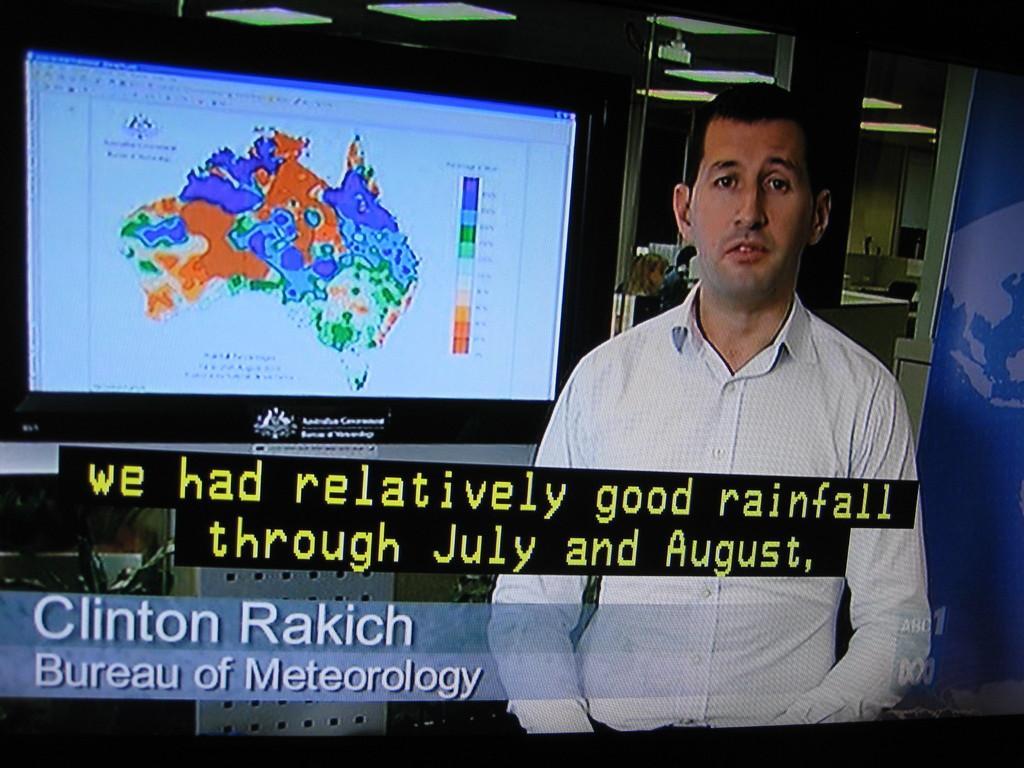In one or two sentences, can you explain what this image depicts? In this image, we can see a man standing and in the background, we can see a television screen, we can see some text. 